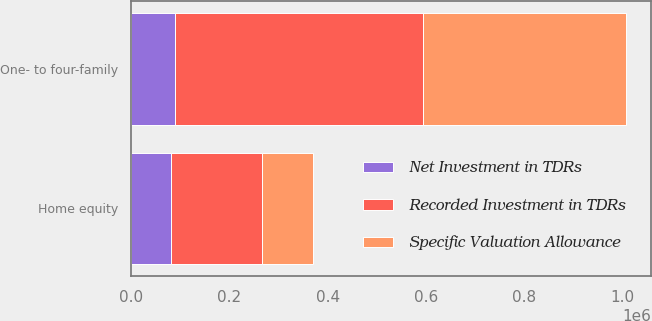Convert chart to OTSL. <chart><loc_0><loc_0><loc_500><loc_500><stacked_bar_chart><ecel><fcel>One- to four-family<fcel>Home equity<nl><fcel>Recorded Investment in TDRs<fcel>503557<fcel>185133<nl><fcel>Net Investment in TDRs<fcel>89684<fcel>81690<nl><fcel>Specific Valuation Allowance<fcel>413873<fcel>103443<nl></chart> 